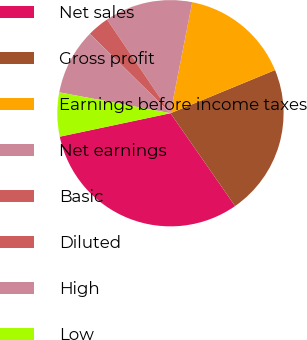<chart> <loc_0><loc_0><loc_500><loc_500><pie_chart><fcel>Net sales<fcel>Gross profit<fcel>Earnings before income taxes<fcel>Net earnings<fcel>Basic<fcel>Diluted<fcel>High<fcel>Low<nl><fcel>31.36%<fcel>21.55%<fcel>15.69%<fcel>12.55%<fcel>3.15%<fcel>0.01%<fcel>9.42%<fcel>6.28%<nl></chart> 